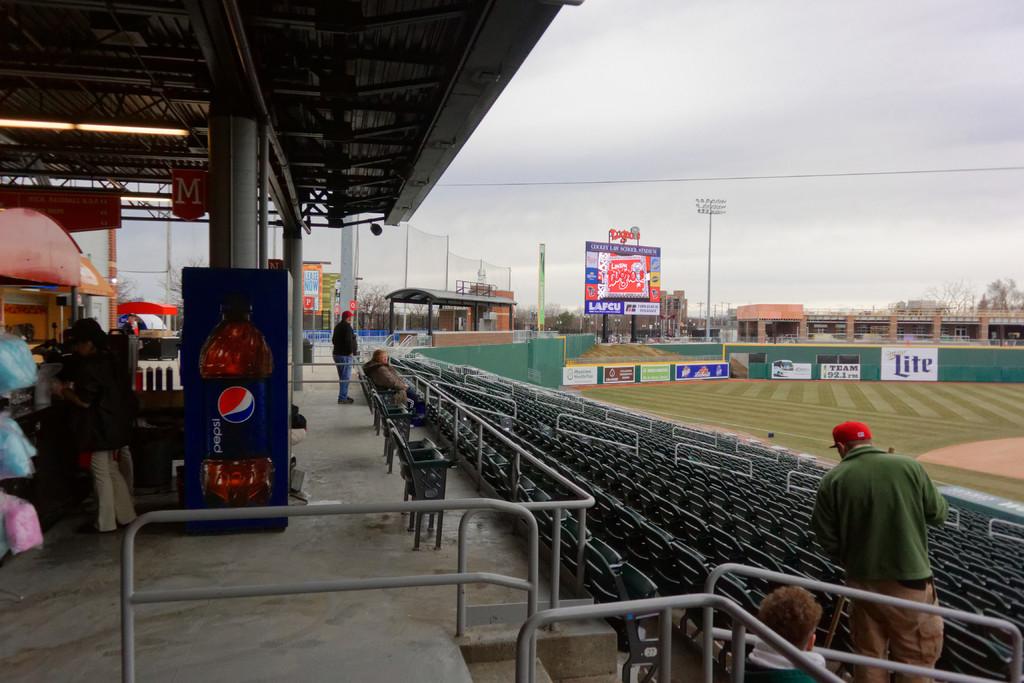What brand of soda is on the side of the machine?
Your answer should be very brief. Pepsi. 